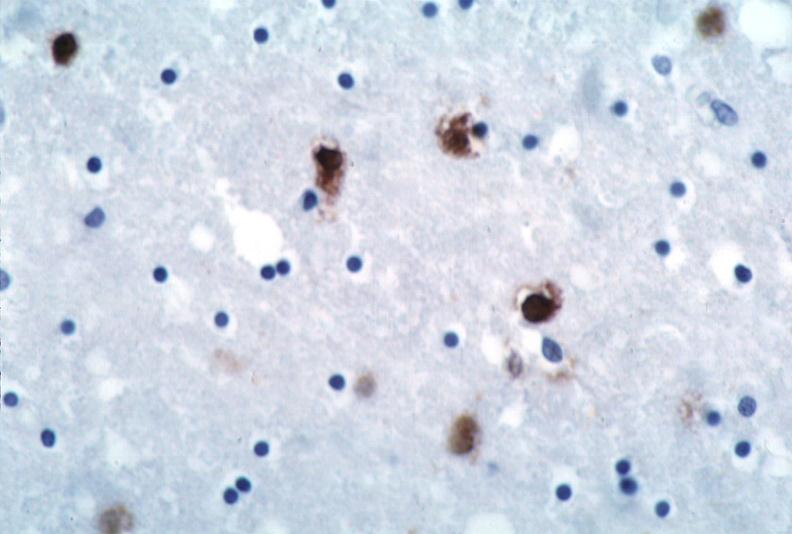does this image show brain, herpes encephalitis?
Answer the question using a single word or phrase. Yes 